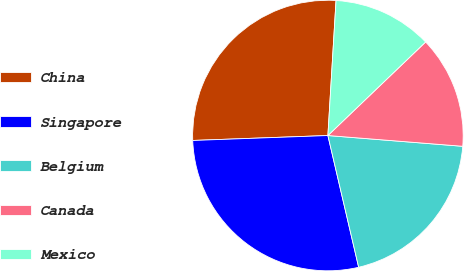Convert chart to OTSL. <chart><loc_0><loc_0><loc_500><loc_500><pie_chart><fcel>China<fcel>Singapore<fcel>Belgium<fcel>Canada<fcel>Mexico<nl><fcel>26.54%<fcel>28.07%<fcel>20.08%<fcel>13.42%<fcel>11.89%<nl></chart> 